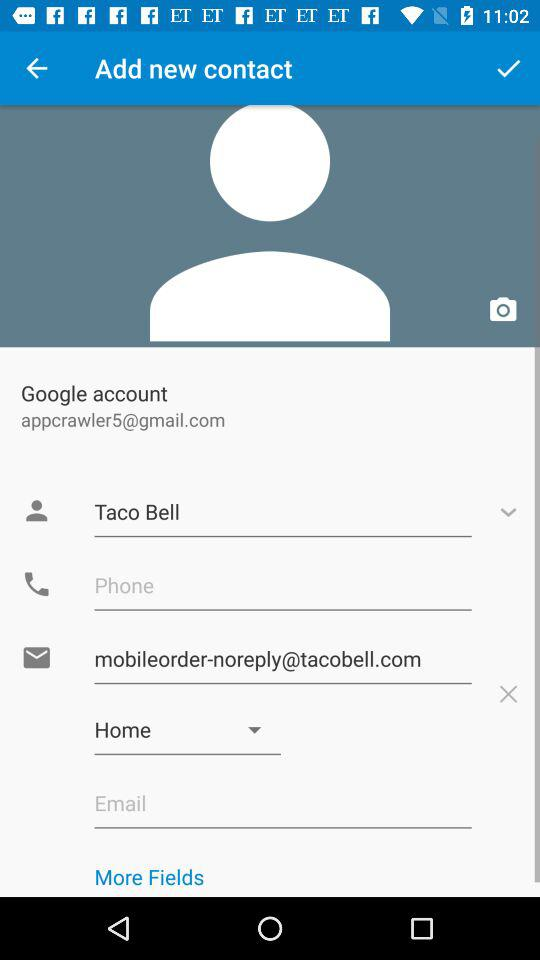What is the name shown on the screen? The name shown on the screen is Taco Bell. 